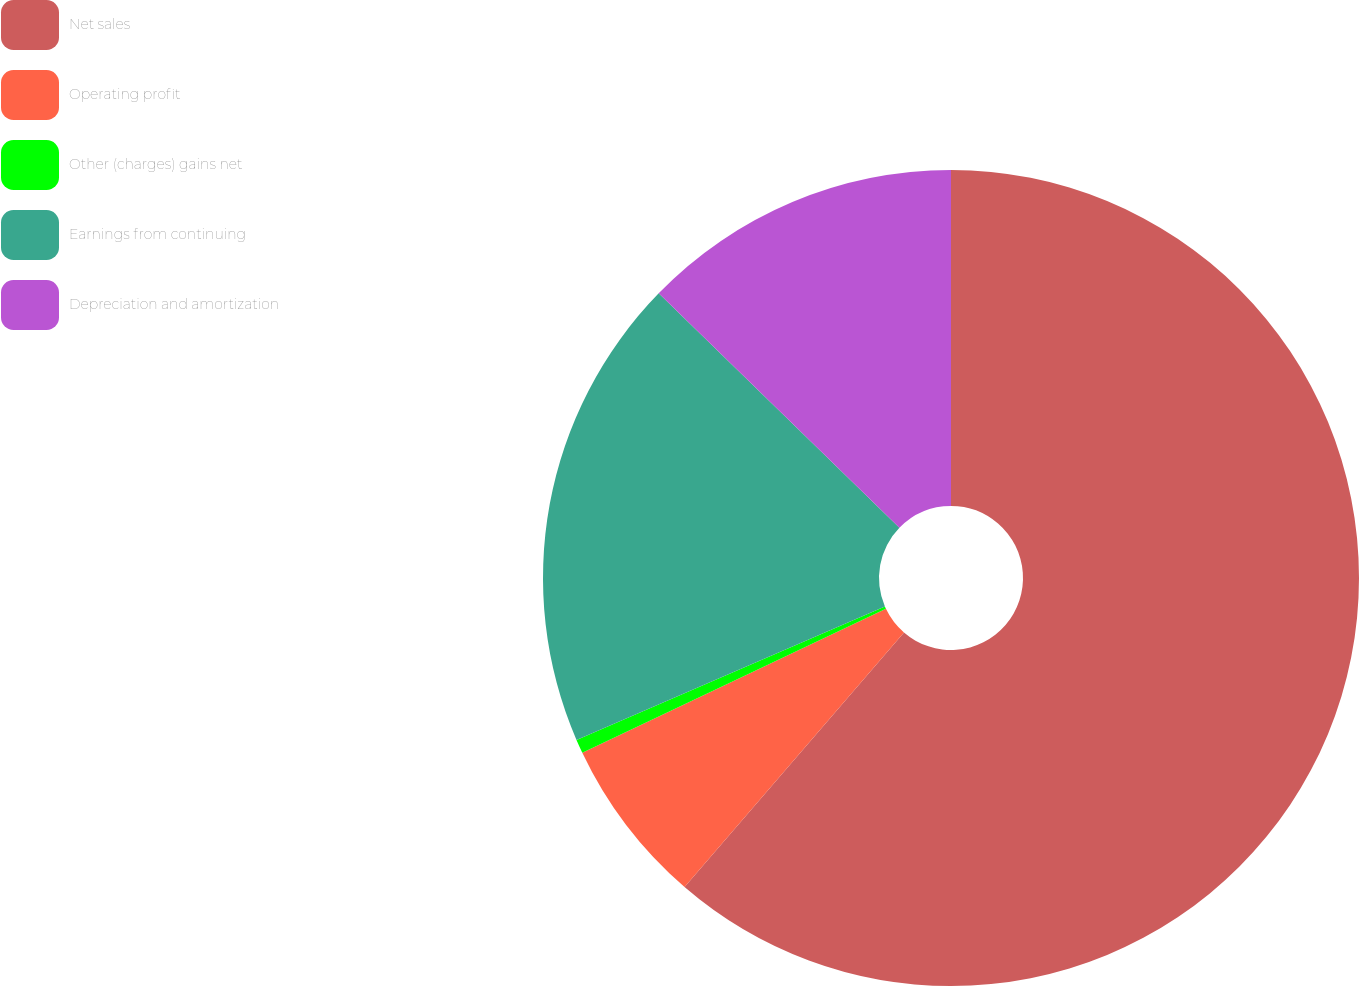Convert chart to OTSL. <chart><loc_0><loc_0><loc_500><loc_500><pie_chart><fcel>Net sales<fcel>Operating profit<fcel>Other (charges) gains net<fcel>Earnings from continuing<fcel>Depreciation and amortization<nl><fcel>61.32%<fcel>6.63%<fcel>0.55%<fcel>18.78%<fcel>12.71%<nl></chart> 